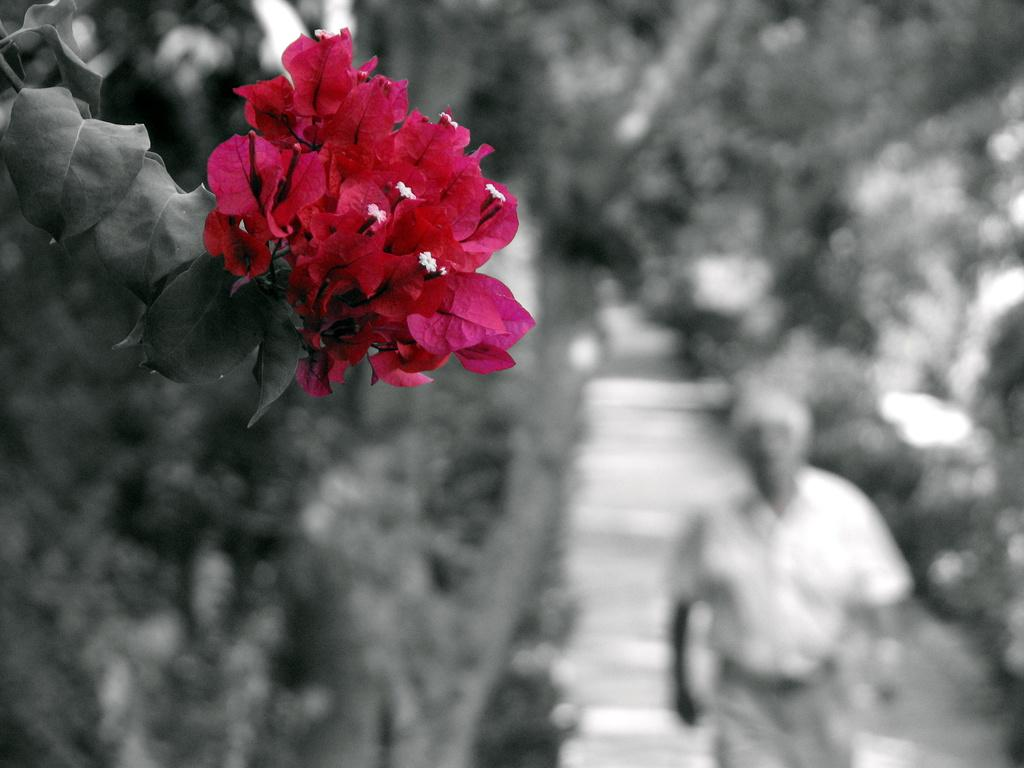What types of plants are visible in the front of the image? There are flowers and leaves in the front of the image. What can be observed about the background of the image? The background of the image is blurry. Are there any living beings visible in the image? Yes, there is a person in the background of the image. What type of disease is affecting the flowers in the image? There is no indication of any disease affecting the flowers in the image. Can you solve the riddle that is written on the leaves in the image? There is no riddle written on the leaves in the image. 